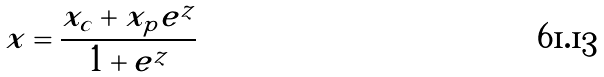Convert formula to latex. <formula><loc_0><loc_0><loc_500><loc_500>x = \frac { x _ { c } + x _ { p } e ^ { z } } { 1 + e ^ { z } }</formula> 